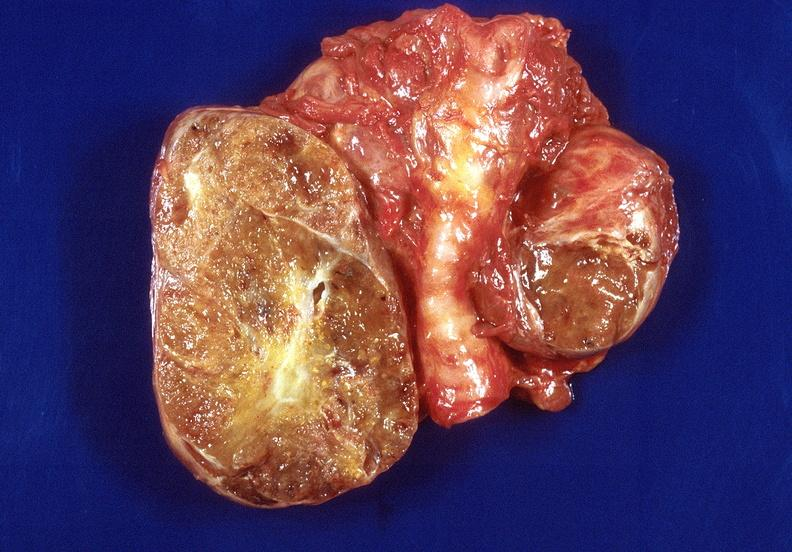does this show thyroid, goiter?
Answer the question using a single word or phrase. No 